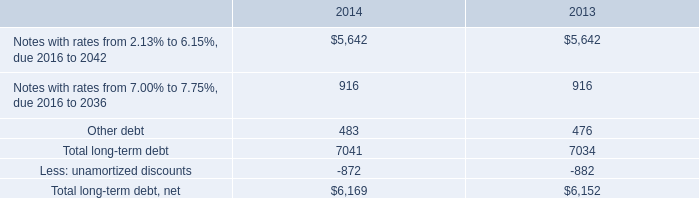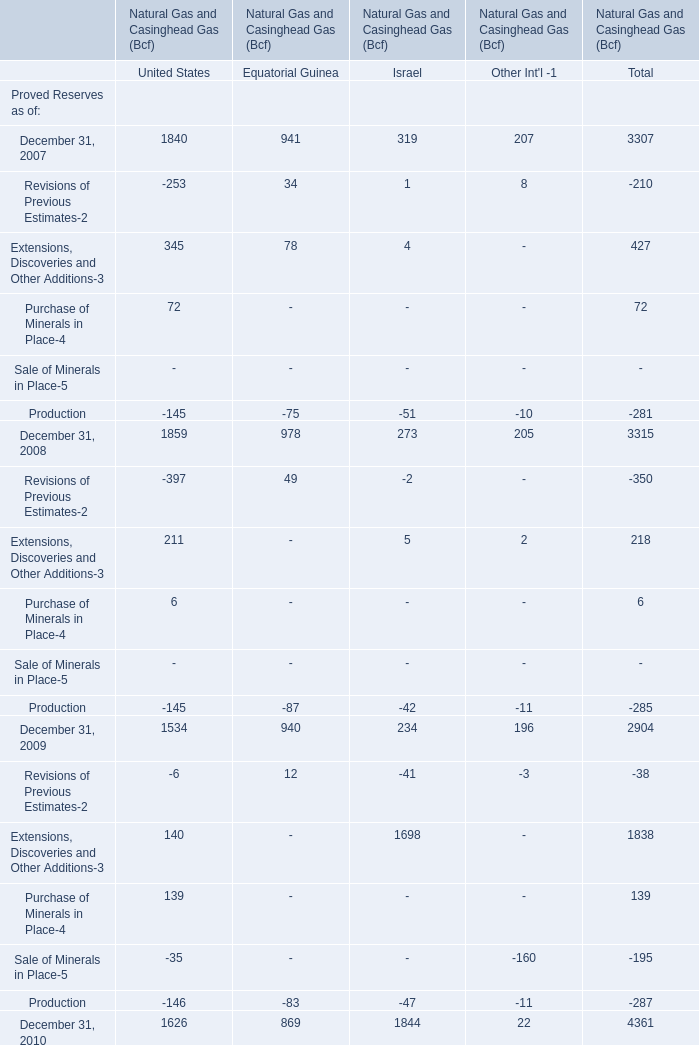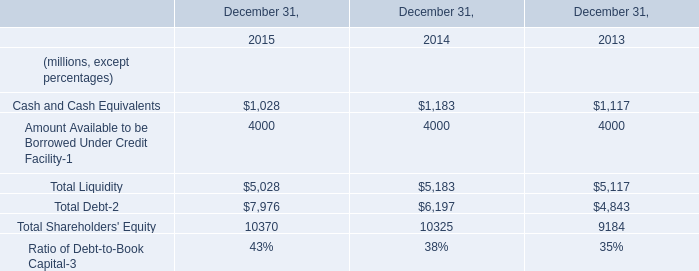What is the sum of the Revisions of Previous Estimates-2 in the years where Production for Equatorial Guinea is greater than -80? 
Computations: (((-253 + 34) + 1) + 8)
Answer: -210.0. 